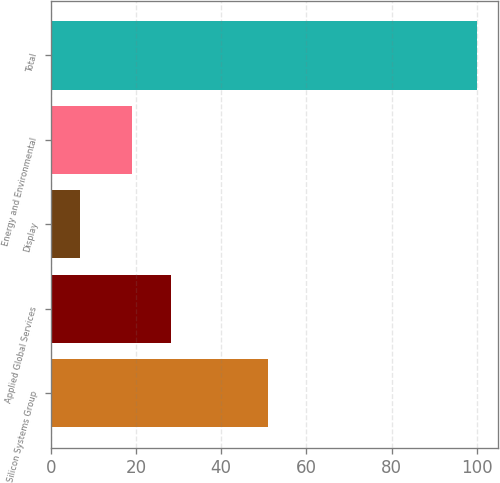Convert chart to OTSL. <chart><loc_0><loc_0><loc_500><loc_500><bar_chart><fcel>Silicon Systems Group<fcel>Applied Global Services<fcel>Display<fcel>Energy and Environmental<fcel>Total<nl><fcel>51<fcel>28.3<fcel>7<fcel>19<fcel>100<nl></chart> 